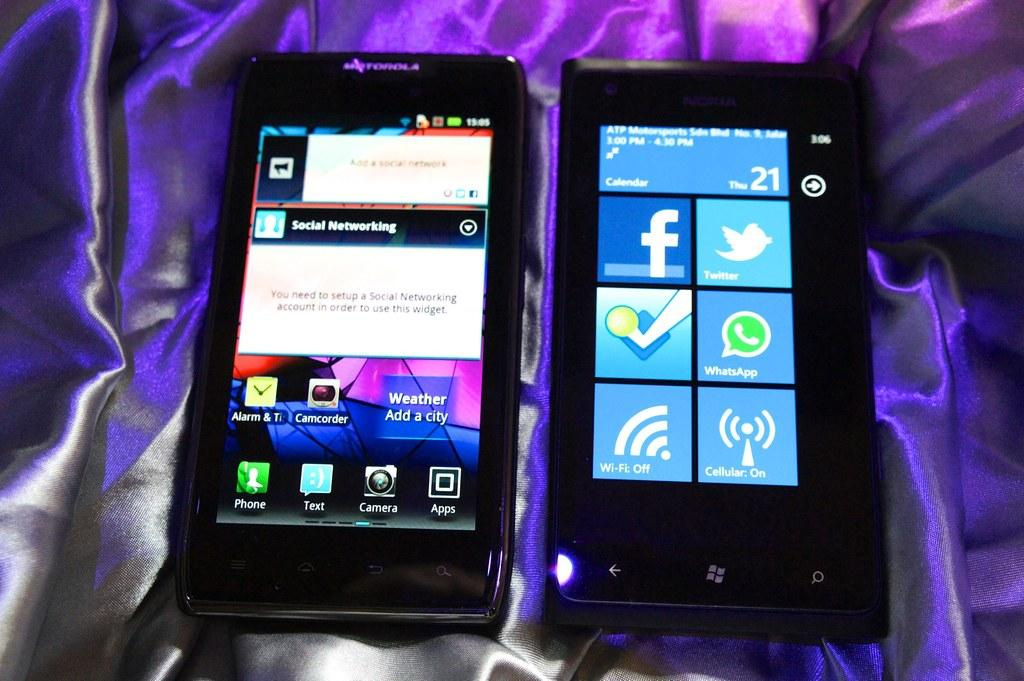<image>
Offer a succinct explanation of the picture presented. The phone on the left is showing a social networking app. 